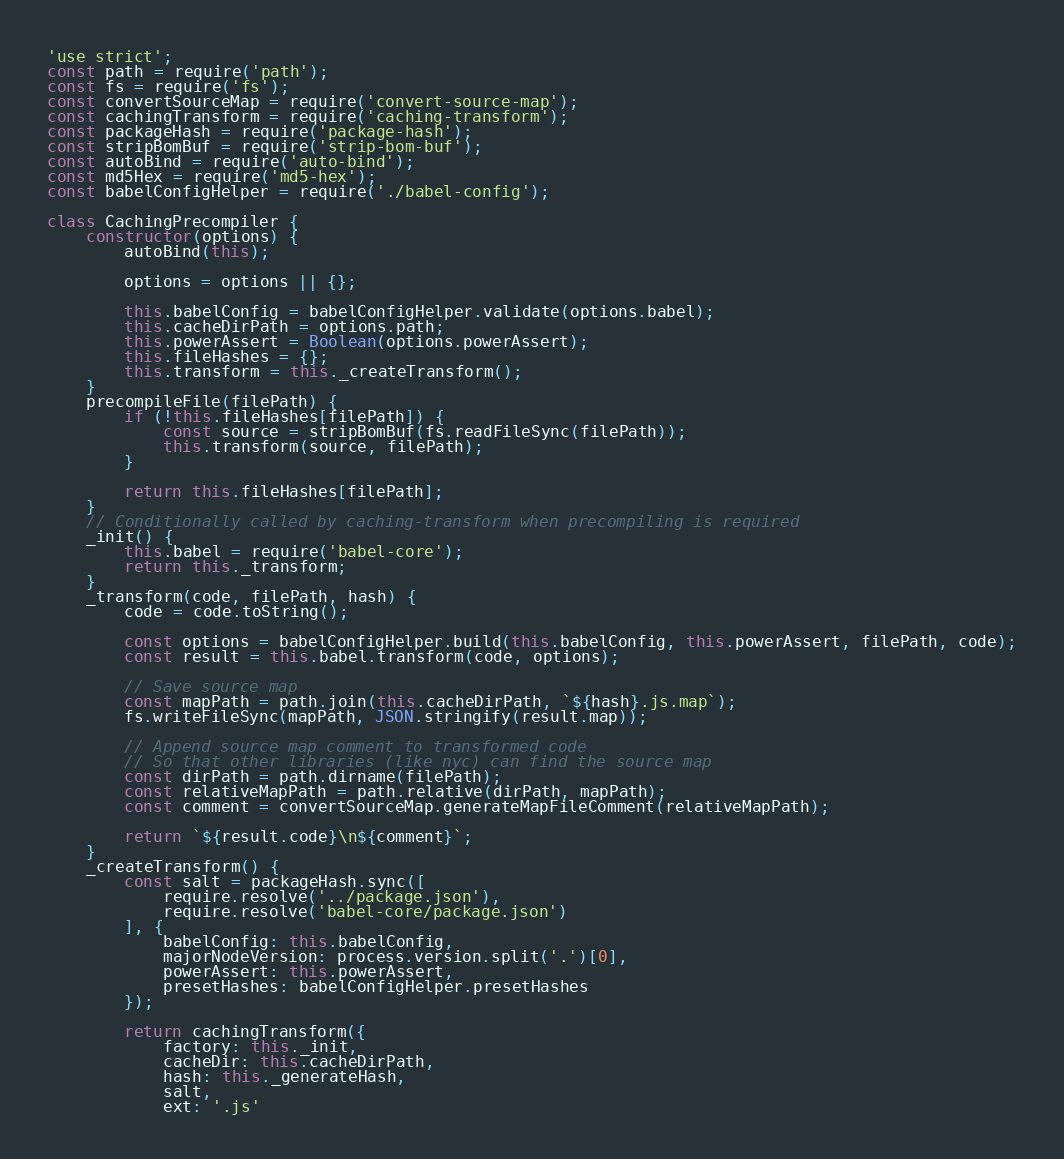<code> <loc_0><loc_0><loc_500><loc_500><_JavaScript_>'use strict';
const path = require('path');
const fs = require('fs');
const convertSourceMap = require('convert-source-map');
const cachingTransform = require('caching-transform');
const packageHash = require('package-hash');
const stripBomBuf = require('strip-bom-buf');
const autoBind = require('auto-bind');
const md5Hex = require('md5-hex');
const babelConfigHelper = require('./babel-config');

class CachingPrecompiler {
	constructor(options) {
		autoBind(this);

		options = options || {};

		this.babelConfig = babelConfigHelper.validate(options.babel);
		this.cacheDirPath = options.path;
		this.powerAssert = Boolean(options.powerAssert);
		this.fileHashes = {};
		this.transform = this._createTransform();
	}
	precompileFile(filePath) {
		if (!this.fileHashes[filePath]) {
			const source = stripBomBuf(fs.readFileSync(filePath));
			this.transform(source, filePath);
		}

		return this.fileHashes[filePath];
	}
	// Conditionally called by caching-transform when precompiling is required
	_init() {
		this.babel = require('babel-core');
		return this._transform;
	}
	_transform(code, filePath, hash) {
		code = code.toString();

		const options = babelConfigHelper.build(this.babelConfig, this.powerAssert, filePath, code);
		const result = this.babel.transform(code, options);

		// Save source map
		const mapPath = path.join(this.cacheDirPath, `${hash}.js.map`);
		fs.writeFileSync(mapPath, JSON.stringify(result.map));

		// Append source map comment to transformed code
		// So that other libraries (like nyc) can find the source map
		const dirPath = path.dirname(filePath);
		const relativeMapPath = path.relative(dirPath, mapPath);
		const comment = convertSourceMap.generateMapFileComment(relativeMapPath);

		return `${result.code}\n${comment}`;
	}
	_createTransform() {
		const salt = packageHash.sync([
			require.resolve('../package.json'),
			require.resolve('babel-core/package.json')
		], {
			babelConfig: this.babelConfig,
			majorNodeVersion: process.version.split('.')[0],
			powerAssert: this.powerAssert,
			presetHashes: babelConfigHelper.presetHashes
		});

		return cachingTransform({
			factory: this._init,
			cacheDir: this.cacheDirPath,
			hash: this._generateHash,
			salt,
			ext: '.js'</code> 